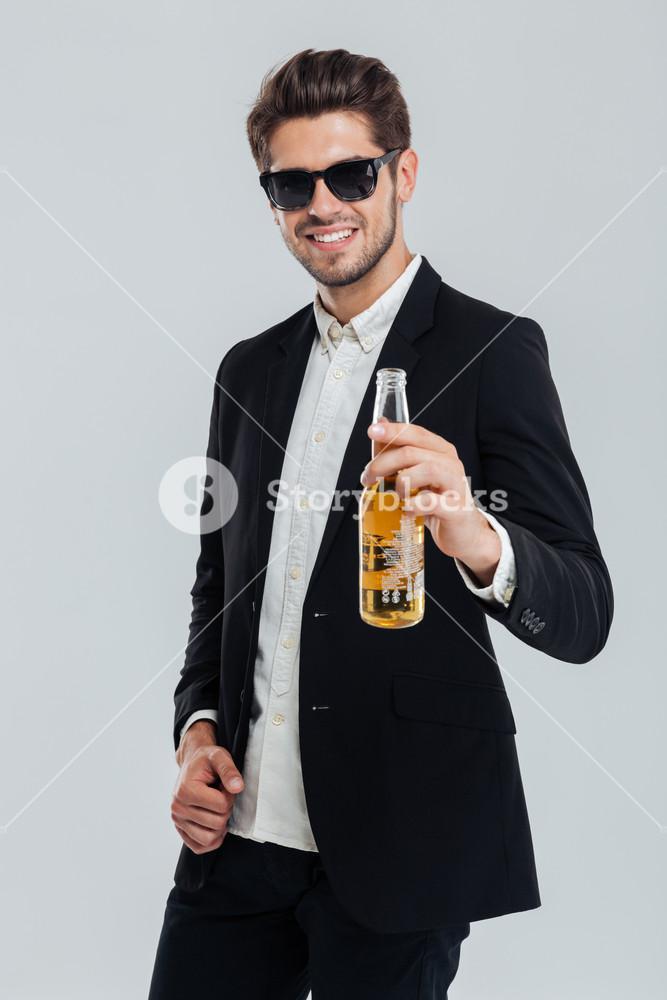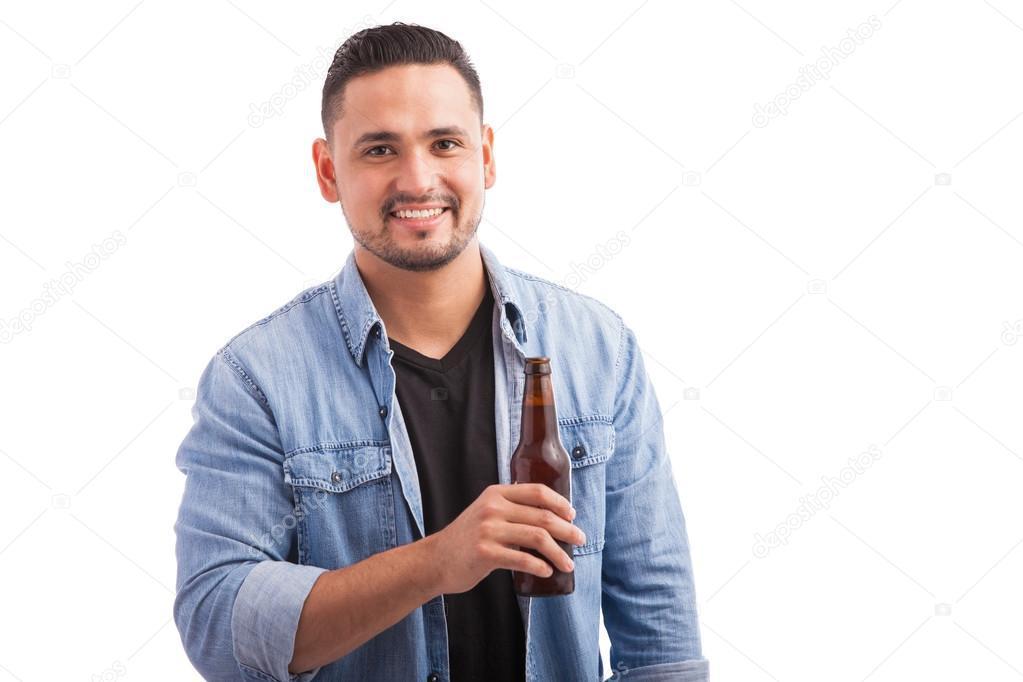The first image is the image on the left, the second image is the image on the right. Analyze the images presented: Is the assertion "The left image shows a man leaning his head back to drink from a brown bottle held in one hand, while the other unraised hand holds another brown bottle." valid? Answer yes or no. No. 